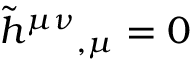Convert formula to latex. <formula><loc_0><loc_0><loc_500><loc_500>{ \tilde { h } } ^ { \mu \nu _ { , \mu } = 0</formula> 